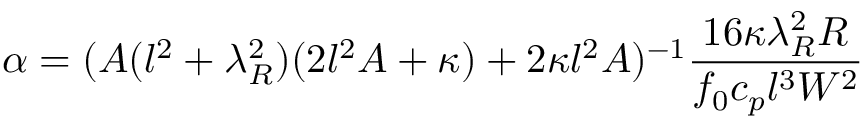Convert formula to latex. <formula><loc_0><loc_0><loc_500><loc_500>\alpha = ( A ( l ^ { 2 } + \lambda _ { R } ^ { 2 } ) ( 2 l ^ { 2 } A + \kappa ) + 2 \kappa l ^ { 2 } A ) ^ { - 1 } \frac { 1 6 \kappa \lambda _ { R } ^ { 2 } R } { f _ { 0 } c _ { p } l ^ { 3 } W ^ { 2 } }</formula> 